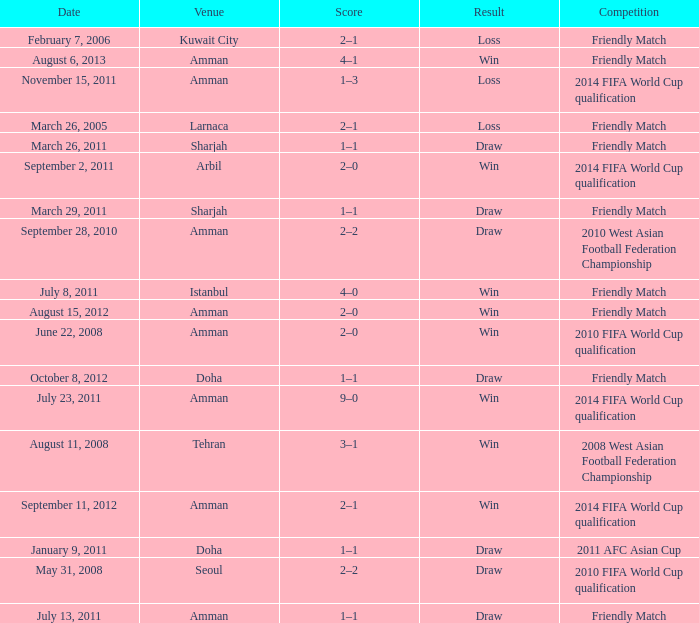During the loss on march 26, 2005, what was the venue where the match was played? Larnaca. 